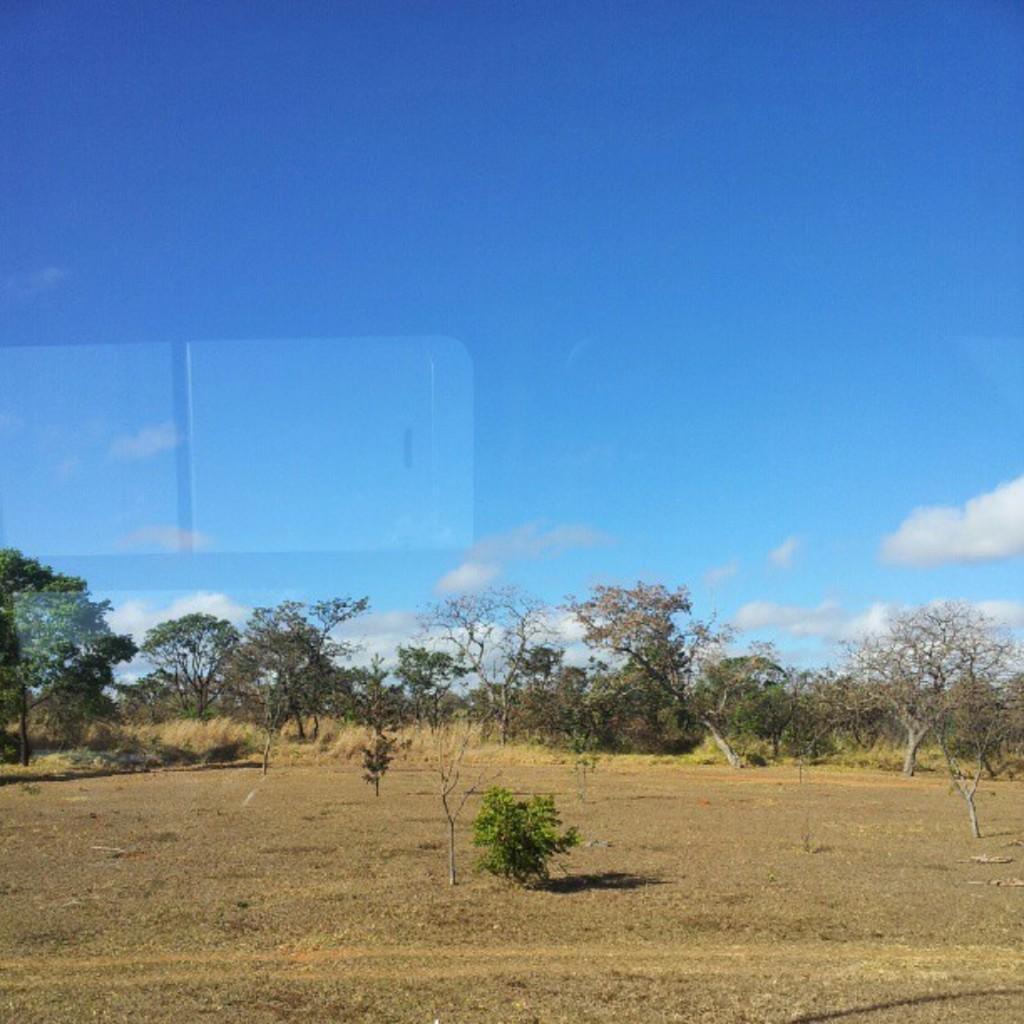Please provide a concise description of this image. In this picture, there are trees and plants at the bottom. At the top, there is a sky with clouds. 